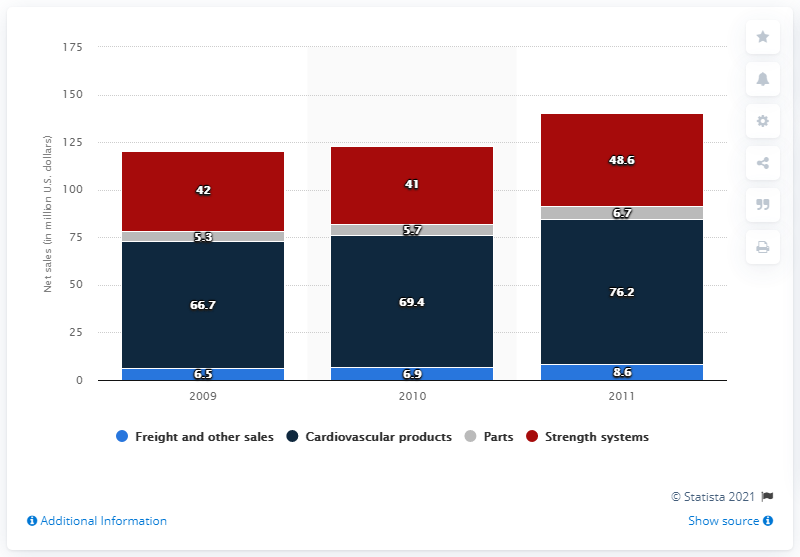Outline some significant characteristics in this image. In 2009, the sales of cardiovascular products reached $66.7 million. 